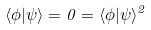Convert formula to latex. <formula><loc_0><loc_0><loc_500><loc_500>\langle \phi | \psi \rangle = 0 = \langle \phi | \psi \rangle ^ { 2 }</formula> 